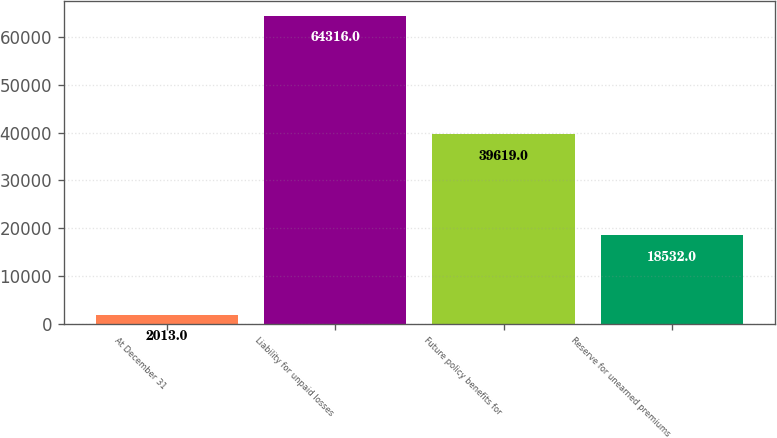Convert chart. <chart><loc_0><loc_0><loc_500><loc_500><bar_chart><fcel>At December 31<fcel>Liability for unpaid losses<fcel>Future policy benefits for<fcel>Reserve for unearned premiums<nl><fcel>2013<fcel>64316<fcel>39619<fcel>18532<nl></chart> 